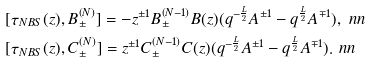Convert formula to latex. <formula><loc_0><loc_0><loc_500><loc_500>& [ \tau _ { N B S } ( z ) , B _ { \pm } ^ { ( N ) } ] = - z ^ { \pm 1 } B _ { \pm } ^ { ( N - 1 ) } B ( z ) ( q ^ { - \frac { L } { 2 } } A ^ { \pm 1 } - q ^ { \frac { L } { 2 } } A ^ { \mp 1 } ) , \ n n \\ & [ \tau _ { N B S } ( z ) , C _ { \pm } ^ { ( N ) } ] = z ^ { \pm 1 } C _ { \pm } ^ { ( N - 1 ) } C ( z ) ( q ^ { - \frac { L } { 2 } } A ^ { \pm 1 } - q ^ { \frac { L } { 2 } } A ^ { \mp 1 } ) . \ n n</formula> 